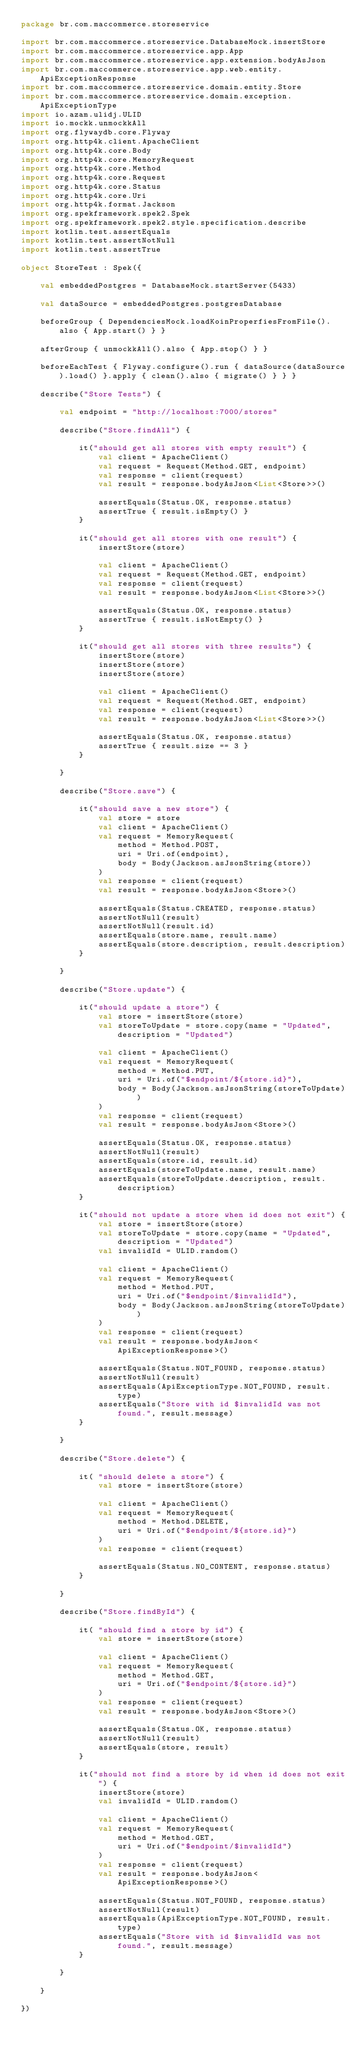Convert code to text. <code><loc_0><loc_0><loc_500><loc_500><_Kotlin_>package br.com.maccommerce.storeservice

import br.com.maccommerce.storeservice.DatabaseMock.insertStore
import br.com.maccommerce.storeservice.app.App
import br.com.maccommerce.storeservice.app.extension.bodyAsJson
import br.com.maccommerce.storeservice.app.web.entity.ApiExceptionResponse
import br.com.maccommerce.storeservice.domain.entity.Store
import br.com.maccommerce.storeservice.domain.exception.ApiExceptionType
import io.azam.ulidj.ULID
import io.mockk.unmockkAll
import org.flywaydb.core.Flyway
import org.http4k.client.ApacheClient
import org.http4k.core.Body
import org.http4k.core.MemoryRequest
import org.http4k.core.Method
import org.http4k.core.Request
import org.http4k.core.Status
import org.http4k.core.Uri
import org.http4k.format.Jackson
import org.spekframework.spek2.Spek
import org.spekframework.spek2.style.specification.describe
import kotlin.test.assertEquals
import kotlin.test.assertNotNull
import kotlin.test.assertTrue

object StoreTest : Spek({

    val embeddedPostgres = DatabaseMock.startServer(5433)

    val dataSource = embeddedPostgres.postgresDatabase

    beforeGroup { DependenciesMock.loadKoinProperfiesFromFile().also { App.start() } }

    afterGroup { unmockkAll().also { App.stop() } }

    beforeEachTest { Flyway.configure().run { dataSource(dataSource).load() }.apply { clean().also { migrate() } } }

    describe("Store Tests") {

        val endpoint = "http://localhost:7000/stores"

        describe("Store.findAll") {

            it("should get all stores with empty result") {
                val client = ApacheClient()
                val request = Request(Method.GET, endpoint)
                val response = client(request)
                val result = response.bodyAsJson<List<Store>>()

                assertEquals(Status.OK, response.status)
                assertTrue { result.isEmpty() }
            }

            it("should get all stores with one result") {
                insertStore(store)

                val client = ApacheClient()
                val request = Request(Method.GET, endpoint)
                val response = client(request)
                val result = response.bodyAsJson<List<Store>>()

                assertEquals(Status.OK, response.status)
                assertTrue { result.isNotEmpty() }
            }

            it("should get all stores with three results") {
                insertStore(store)
                insertStore(store)
                insertStore(store)

                val client = ApacheClient()
                val request = Request(Method.GET, endpoint)
                val response = client(request)
                val result = response.bodyAsJson<List<Store>>()

                assertEquals(Status.OK, response.status)
                assertTrue { result.size == 3 }
            }

        }

        describe("Store.save") {

            it("should save a new store") {
                val store = store
                val client = ApacheClient()
                val request = MemoryRequest(
                    method = Method.POST,
                    uri = Uri.of(endpoint),
                    body = Body(Jackson.asJsonString(store))
                )
                val response = client(request)
                val result = response.bodyAsJson<Store>()

                assertEquals(Status.CREATED, response.status)
                assertNotNull(result)
                assertNotNull(result.id)
                assertEquals(store.name, result.name)
                assertEquals(store.description, result.description)
            }

        }

        describe("Store.update") {

            it("should update a store") {
                val store = insertStore(store)
                val storeToUpdate = store.copy(name = "Updated", description = "Updated")

                val client = ApacheClient()
                val request = MemoryRequest(
                    method = Method.PUT,
                    uri = Uri.of("$endpoint/${store.id}"),
                    body = Body(Jackson.asJsonString(storeToUpdate))
                )
                val response = client(request)
                val result = response.bodyAsJson<Store>()

                assertEquals(Status.OK, response.status)
                assertNotNull(result)
                assertEquals(store.id, result.id)
                assertEquals(storeToUpdate.name, result.name)
                assertEquals(storeToUpdate.description, result.description)
            }

            it("should not update a store when id does not exit") {
                val store = insertStore(store)
                val storeToUpdate = store.copy(name = "Updated", description = "Updated")
                val invalidId = ULID.random()

                val client = ApacheClient()
                val request = MemoryRequest(
                    method = Method.PUT,
                    uri = Uri.of("$endpoint/$invalidId"),
                    body = Body(Jackson.asJsonString(storeToUpdate))
                )
                val response = client(request)
                val result = response.bodyAsJson<ApiExceptionResponse>()

                assertEquals(Status.NOT_FOUND, response.status)
                assertNotNull(result)
                assertEquals(ApiExceptionType.NOT_FOUND, result.type)
                assertEquals("Store with id $invalidId was not found.", result.message)
            }

        }

        describe("Store.delete") {

            it( "should delete a store") {
                val store = insertStore(store)

                val client = ApacheClient()
                val request = MemoryRequest(
                    method = Method.DELETE,
                    uri = Uri.of("$endpoint/${store.id}")
                )
                val response = client(request)

                assertEquals(Status.NO_CONTENT, response.status)
            }

        }

        describe("Store.findById") {

            it( "should find a store by id") {
                val store = insertStore(store)

                val client = ApacheClient()
                val request = MemoryRequest(
                    method = Method.GET,
                    uri = Uri.of("$endpoint/${store.id}")
                )
                val response = client(request)
                val result = response.bodyAsJson<Store>()

                assertEquals(Status.OK, response.status)
                assertNotNull(result)
                assertEquals(store, result)
            }

            it("should not find a store by id when id does not exit") {
                insertStore(store)
                val invalidId = ULID.random()

                val client = ApacheClient()
                val request = MemoryRequest(
                    method = Method.GET,
                    uri = Uri.of("$endpoint/$invalidId")
                )
                val response = client(request)
                val result = response.bodyAsJson<ApiExceptionResponse>()

                assertEquals(Status.NOT_FOUND, response.status)
                assertNotNull(result)
                assertEquals(ApiExceptionType.NOT_FOUND, result.type)
                assertEquals("Store with id $invalidId was not found.", result.message)
            }

        }

    }

})
</code> 